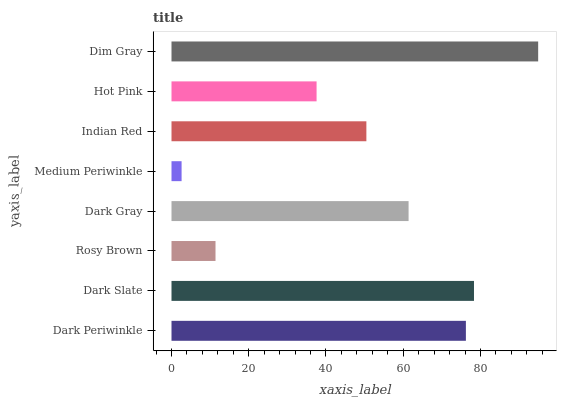Is Medium Periwinkle the minimum?
Answer yes or no. Yes. Is Dim Gray the maximum?
Answer yes or no. Yes. Is Dark Slate the minimum?
Answer yes or no. No. Is Dark Slate the maximum?
Answer yes or no. No. Is Dark Slate greater than Dark Periwinkle?
Answer yes or no. Yes. Is Dark Periwinkle less than Dark Slate?
Answer yes or no. Yes. Is Dark Periwinkle greater than Dark Slate?
Answer yes or no. No. Is Dark Slate less than Dark Periwinkle?
Answer yes or no. No. Is Dark Gray the high median?
Answer yes or no. Yes. Is Indian Red the low median?
Answer yes or no. Yes. Is Dark Slate the high median?
Answer yes or no. No. Is Rosy Brown the low median?
Answer yes or no. No. 